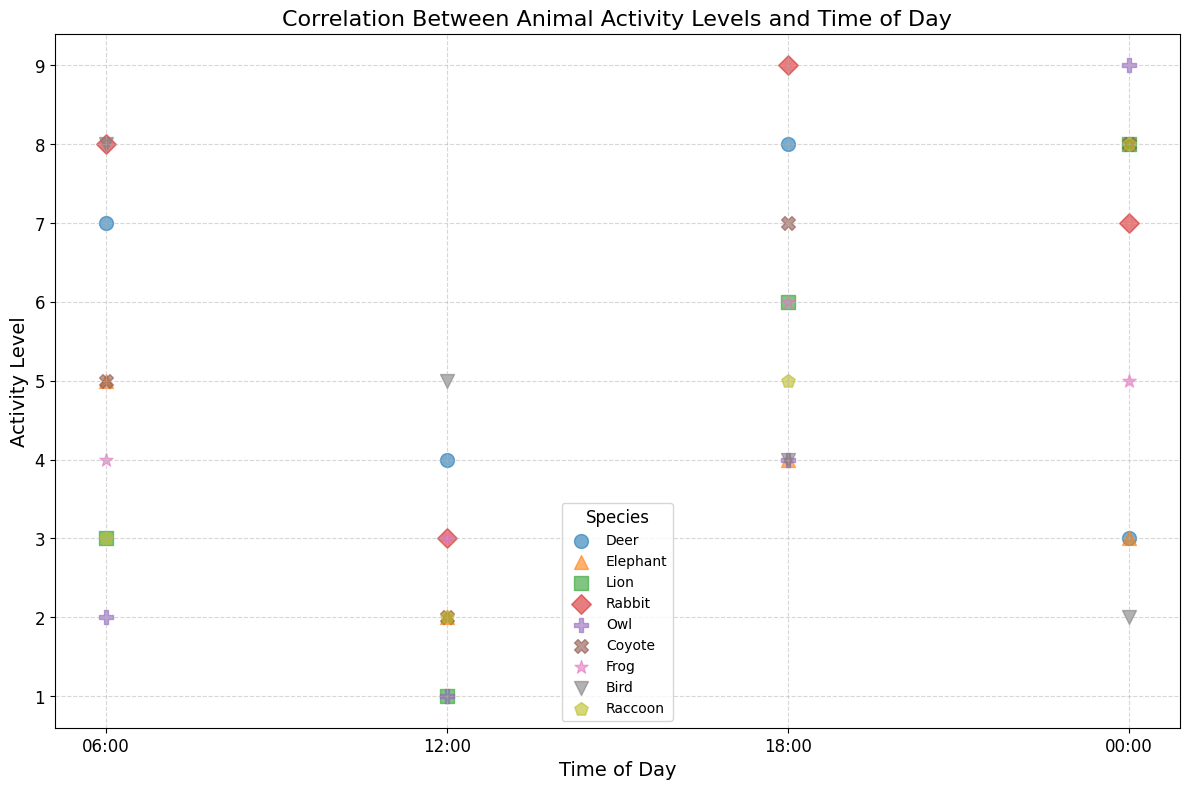What time of day does the Lion show the highest activity level? By looking at the scatter plot, we can see that the activity level for the Lion is highest at 00:00 (midnight).
Answer: 00:00 Which species shows the most significant increase in activity level from 12:00 to 18:00? Comparing the difference between the activity levels at 12:00 and 18:00 for all species, the Lion shows the most significant increase (from 1 to 6, a difference of 5).
Answer: Lion What are the average activity levels of Deer and Rabbit at 18:00? The activity levels for Deer and Rabbit at 18:00 are 8 and 9, respectively. The average is (8 + 9) / 2 = 8.5.
Answer: 8.5 Which species has a higher activity level at midnight compared to 18:00? By comparing the activity levels at 00:00 and 18:00, the Lion's activity level increases from 6 to 8, and the Owl's from 4 to 9. Both Lions and Owls show higher activity levels at midnight.
Answer: Lion, Owl What is the median activity level for the Bird across all times of day? The activity levels for the Bird are 8, 5, 4, and 2. Sorting these values (2, 4, 5, 8), the median is the average of the two middle numbers, which is (4 + 5) / 2 = 4.5.
Answer: 4.5 Which species has the least variation in activity level throughout the day? By observing the range (max - min) of activity levels for each species, the Elephant's activity levels range from 2 to 5, a difference of 3, which is the smallest variation.
Answer: Elephant How does the Rabbit's activity level change from morning (06:00) to afternoon (12:00)? For the Rabbit, the activity level changes from 8 at 06:00 to 3 at 12:00, which is a decrease of 5.
Answer: Decreases by 5 Which species is most active during the daytime (06:00 and 12:00)? Comparing activity levels at 06:00 and 12:00, the Bird shows the highest combined daytime activity level (8 at 06:00 and 5 at 12:00, totaling 13).
Answer: Bird What is the total activity level for the Coyote throughout the day? Summing up the Coyotes' activity levels across all times (5+2+7+8), the total activity level is 22.
Answer: 22 Does any species have an activity level of 9 at any time point? By reviewing the scatter plot, we see that the Rabbit and Owl both have an activity level of 9 at certain times.
Answer: Yes 